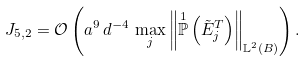<formula> <loc_0><loc_0><loc_500><loc_500>J _ { 5 , 2 } = \mathcal { O } \left ( a ^ { 9 } \, d ^ { - 4 } \, \max _ { j } \left \| \overset { 1 } { \mathbb { P } } \left ( \tilde { E } ^ { T } _ { j } \right ) \right \| _ { \mathbb { L } ^ { 2 } ( B ) } \right ) .</formula> 